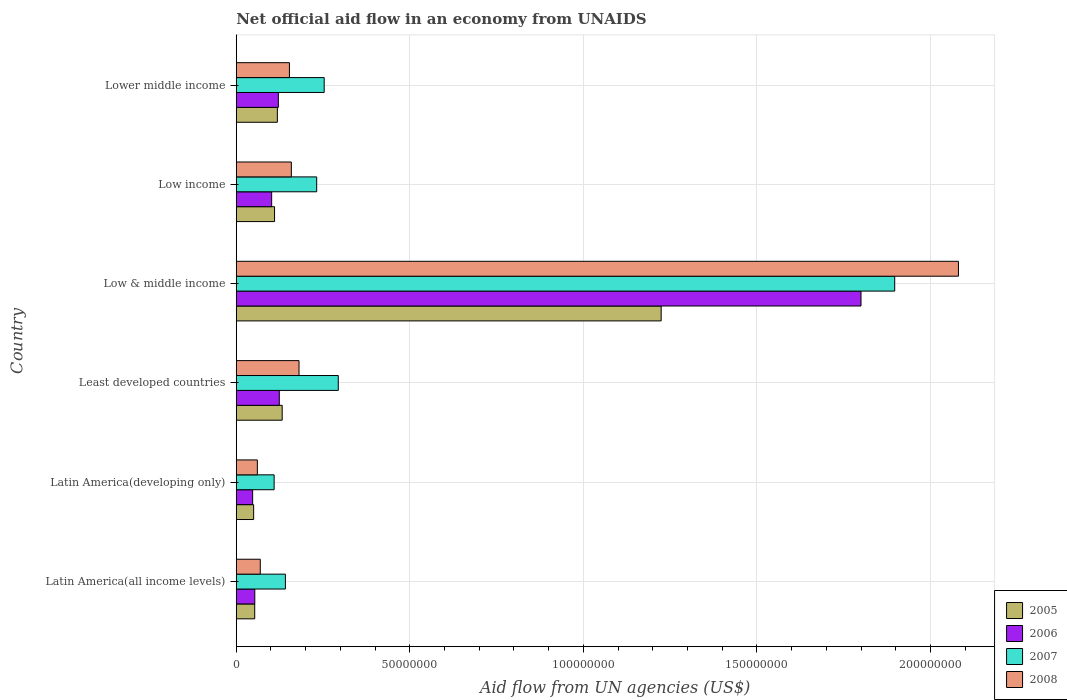How many groups of bars are there?
Provide a succinct answer. 6. Are the number of bars on each tick of the Y-axis equal?
Offer a terse response. Yes. How many bars are there on the 5th tick from the top?
Keep it short and to the point. 4. How many bars are there on the 1st tick from the bottom?
Your answer should be very brief. 4. What is the label of the 5th group of bars from the top?
Give a very brief answer. Latin America(developing only). What is the net official aid flow in 2008 in Latin America(developing only)?
Your response must be concise. 6.08e+06. Across all countries, what is the maximum net official aid flow in 2008?
Ensure brevity in your answer.  2.08e+08. Across all countries, what is the minimum net official aid flow in 2006?
Offer a terse response. 4.72e+06. In which country was the net official aid flow in 2008 minimum?
Ensure brevity in your answer.  Latin America(developing only). What is the total net official aid flow in 2005 in the graph?
Offer a very short reply. 1.69e+08. What is the difference between the net official aid flow in 2006 in Latin America(all income levels) and that in Low & middle income?
Provide a succinct answer. -1.75e+08. What is the difference between the net official aid flow in 2005 in Lower middle income and the net official aid flow in 2007 in Least developed countries?
Make the answer very short. -1.76e+07. What is the average net official aid flow in 2008 per country?
Give a very brief answer. 4.50e+07. What is the difference between the net official aid flow in 2007 and net official aid flow in 2006 in Latin America(all income levels)?
Offer a terse response. 8.82e+06. What is the ratio of the net official aid flow in 2008 in Latin America(all income levels) to that in Lower middle income?
Make the answer very short. 0.45. Is the net official aid flow in 2006 in Latin America(all income levels) less than that in Low & middle income?
Provide a succinct answer. Yes. Is the difference between the net official aid flow in 2007 in Latin America(all income levels) and Least developed countries greater than the difference between the net official aid flow in 2006 in Latin America(all income levels) and Least developed countries?
Ensure brevity in your answer.  No. What is the difference between the highest and the second highest net official aid flow in 2007?
Your response must be concise. 1.60e+08. What is the difference between the highest and the lowest net official aid flow in 2006?
Provide a short and direct response. 1.75e+08. In how many countries, is the net official aid flow in 2006 greater than the average net official aid flow in 2006 taken over all countries?
Ensure brevity in your answer.  1. Is the sum of the net official aid flow in 2007 in Low & middle income and Low income greater than the maximum net official aid flow in 2008 across all countries?
Your answer should be compact. Yes. What does the 1st bar from the bottom in Least developed countries represents?
Your response must be concise. 2005. Is it the case that in every country, the sum of the net official aid flow in 2005 and net official aid flow in 2006 is greater than the net official aid flow in 2007?
Keep it short and to the point. No. How many bars are there?
Your answer should be very brief. 24. Are all the bars in the graph horizontal?
Provide a succinct answer. Yes. Are the values on the major ticks of X-axis written in scientific E-notation?
Provide a short and direct response. No. Does the graph contain any zero values?
Keep it short and to the point. No. Does the graph contain grids?
Ensure brevity in your answer.  Yes. How many legend labels are there?
Ensure brevity in your answer.  4. What is the title of the graph?
Provide a succinct answer. Net official aid flow in an economy from UNAIDS. Does "2012" appear as one of the legend labels in the graph?
Make the answer very short. No. What is the label or title of the X-axis?
Give a very brief answer. Aid flow from UN agencies (US$). What is the Aid flow from UN agencies (US$) of 2005 in Latin America(all income levels)?
Your answer should be compact. 5.32e+06. What is the Aid flow from UN agencies (US$) in 2006 in Latin America(all income levels)?
Make the answer very short. 5.34e+06. What is the Aid flow from UN agencies (US$) of 2007 in Latin America(all income levels)?
Your response must be concise. 1.42e+07. What is the Aid flow from UN agencies (US$) in 2008 in Latin America(all income levels)?
Ensure brevity in your answer.  6.92e+06. What is the Aid flow from UN agencies (US$) of 2005 in Latin America(developing only)?
Your answer should be very brief. 5.01e+06. What is the Aid flow from UN agencies (US$) in 2006 in Latin America(developing only)?
Make the answer very short. 4.72e+06. What is the Aid flow from UN agencies (US$) of 2007 in Latin America(developing only)?
Ensure brevity in your answer.  1.09e+07. What is the Aid flow from UN agencies (US$) in 2008 in Latin America(developing only)?
Provide a succinct answer. 6.08e+06. What is the Aid flow from UN agencies (US$) in 2005 in Least developed countries?
Provide a succinct answer. 1.32e+07. What is the Aid flow from UN agencies (US$) in 2006 in Least developed countries?
Offer a very short reply. 1.24e+07. What is the Aid flow from UN agencies (US$) in 2007 in Least developed countries?
Provide a succinct answer. 2.94e+07. What is the Aid flow from UN agencies (US$) in 2008 in Least developed countries?
Offer a terse response. 1.81e+07. What is the Aid flow from UN agencies (US$) of 2005 in Low & middle income?
Your answer should be very brief. 1.22e+08. What is the Aid flow from UN agencies (US$) in 2006 in Low & middle income?
Your answer should be very brief. 1.80e+08. What is the Aid flow from UN agencies (US$) of 2007 in Low & middle income?
Ensure brevity in your answer.  1.90e+08. What is the Aid flow from UN agencies (US$) of 2008 in Low & middle income?
Provide a short and direct response. 2.08e+08. What is the Aid flow from UN agencies (US$) of 2005 in Low income?
Ensure brevity in your answer.  1.10e+07. What is the Aid flow from UN agencies (US$) of 2006 in Low income?
Your response must be concise. 1.02e+07. What is the Aid flow from UN agencies (US$) of 2007 in Low income?
Keep it short and to the point. 2.32e+07. What is the Aid flow from UN agencies (US$) of 2008 in Low income?
Your response must be concise. 1.59e+07. What is the Aid flow from UN agencies (US$) of 2005 in Lower middle income?
Your answer should be compact. 1.18e+07. What is the Aid flow from UN agencies (US$) of 2006 in Lower middle income?
Offer a terse response. 1.21e+07. What is the Aid flow from UN agencies (US$) of 2007 in Lower middle income?
Keep it short and to the point. 2.53e+07. What is the Aid flow from UN agencies (US$) in 2008 in Lower middle income?
Your response must be concise. 1.53e+07. Across all countries, what is the maximum Aid flow from UN agencies (US$) of 2005?
Provide a short and direct response. 1.22e+08. Across all countries, what is the maximum Aid flow from UN agencies (US$) of 2006?
Your response must be concise. 1.80e+08. Across all countries, what is the maximum Aid flow from UN agencies (US$) in 2007?
Your answer should be very brief. 1.90e+08. Across all countries, what is the maximum Aid flow from UN agencies (US$) of 2008?
Offer a very short reply. 2.08e+08. Across all countries, what is the minimum Aid flow from UN agencies (US$) in 2005?
Ensure brevity in your answer.  5.01e+06. Across all countries, what is the minimum Aid flow from UN agencies (US$) in 2006?
Provide a succinct answer. 4.72e+06. Across all countries, what is the minimum Aid flow from UN agencies (US$) in 2007?
Your answer should be very brief. 1.09e+07. Across all countries, what is the minimum Aid flow from UN agencies (US$) in 2008?
Provide a short and direct response. 6.08e+06. What is the total Aid flow from UN agencies (US$) of 2005 in the graph?
Your response must be concise. 1.69e+08. What is the total Aid flow from UN agencies (US$) of 2006 in the graph?
Your answer should be very brief. 2.25e+08. What is the total Aid flow from UN agencies (US$) of 2007 in the graph?
Give a very brief answer. 2.93e+08. What is the total Aid flow from UN agencies (US$) of 2008 in the graph?
Keep it short and to the point. 2.70e+08. What is the difference between the Aid flow from UN agencies (US$) of 2005 in Latin America(all income levels) and that in Latin America(developing only)?
Your answer should be very brief. 3.10e+05. What is the difference between the Aid flow from UN agencies (US$) of 2006 in Latin America(all income levels) and that in Latin America(developing only)?
Give a very brief answer. 6.20e+05. What is the difference between the Aid flow from UN agencies (US$) in 2007 in Latin America(all income levels) and that in Latin America(developing only)?
Make the answer very short. 3.25e+06. What is the difference between the Aid flow from UN agencies (US$) of 2008 in Latin America(all income levels) and that in Latin America(developing only)?
Keep it short and to the point. 8.40e+05. What is the difference between the Aid flow from UN agencies (US$) of 2005 in Latin America(all income levels) and that in Least developed countries?
Provide a short and direct response. -7.91e+06. What is the difference between the Aid flow from UN agencies (US$) in 2006 in Latin America(all income levels) and that in Least developed countries?
Provide a succinct answer. -7.06e+06. What is the difference between the Aid flow from UN agencies (US$) of 2007 in Latin America(all income levels) and that in Least developed countries?
Keep it short and to the point. -1.52e+07. What is the difference between the Aid flow from UN agencies (US$) of 2008 in Latin America(all income levels) and that in Least developed countries?
Ensure brevity in your answer.  -1.12e+07. What is the difference between the Aid flow from UN agencies (US$) in 2005 in Latin America(all income levels) and that in Low & middle income?
Your answer should be compact. -1.17e+08. What is the difference between the Aid flow from UN agencies (US$) of 2006 in Latin America(all income levels) and that in Low & middle income?
Give a very brief answer. -1.75e+08. What is the difference between the Aid flow from UN agencies (US$) in 2007 in Latin America(all income levels) and that in Low & middle income?
Ensure brevity in your answer.  -1.76e+08. What is the difference between the Aid flow from UN agencies (US$) of 2008 in Latin America(all income levels) and that in Low & middle income?
Offer a very short reply. -2.01e+08. What is the difference between the Aid flow from UN agencies (US$) of 2005 in Latin America(all income levels) and that in Low income?
Provide a short and direct response. -5.71e+06. What is the difference between the Aid flow from UN agencies (US$) in 2006 in Latin America(all income levels) and that in Low income?
Your answer should be compact. -4.86e+06. What is the difference between the Aid flow from UN agencies (US$) of 2007 in Latin America(all income levels) and that in Low income?
Provide a succinct answer. -9.01e+06. What is the difference between the Aid flow from UN agencies (US$) in 2008 in Latin America(all income levels) and that in Low income?
Ensure brevity in your answer.  -8.95e+06. What is the difference between the Aid flow from UN agencies (US$) in 2005 in Latin America(all income levels) and that in Lower middle income?
Your response must be concise. -6.52e+06. What is the difference between the Aid flow from UN agencies (US$) in 2006 in Latin America(all income levels) and that in Lower middle income?
Your response must be concise. -6.79e+06. What is the difference between the Aid flow from UN agencies (US$) in 2007 in Latin America(all income levels) and that in Lower middle income?
Offer a very short reply. -1.12e+07. What is the difference between the Aid flow from UN agencies (US$) in 2008 in Latin America(all income levels) and that in Lower middle income?
Provide a short and direct response. -8.40e+06. What is the difference between the Aid flow from UN agencies (US$) in 2005 in Latin America(developing only) and that in Least developed countries?
Give a very brief answer. -8.22e+06. What is the difference between the Aid flow from UN agencies (US$) of 2006 in Latin America(developing only) and that in Least developed countries?
Provide a succinct answer. -7.68e+06. What is the difference between the Aid flow from UN agencies (US$) of 2007 in Latin America(developing only) and that in Least developed countries?
Provide a succinct answer. -1.85e+07. What is the difference between the Aid flow from UN agencies (US$) of 2008 in Latin America(developing only) and that in Least developed countries?
Make the answer very short. -1.20e+07. What is the difference between the Aid flow from UN agencies (US$) of 2005 in Latin America(developing only) and that in Low & middle income?
Your answer should be compact. -1.17e+08. What is the difference between the Aid flow from UN agencies (US$) in 2006 in Latin America(developing only) and that in Low & middle income?
Give a very brief answer. -1.75e+08. What is the difference between the Aid flow from UN agencies (US$) in 2007 in Latin America(developing only) and that in Low & middle income?
Provide a short and direct response. -1.79e+08. What is the difference between the Aid flow from UN agencies (US$) in 2008 in Latin America(developing only) and that in Low & middle income?
Provide a short and direct response. -2.02e+08. What is the difference between the Aid flow from UN agencies (US$) in 2005 in Latin America(developing only) and that in Low income?
Keep it short and to the point. -6.02e+06. What is the difference between the Aid flow from UN agencies (US$) in 2006 in Latin America(developing only) and that in Low income?
Your answer should be very brief. -5.48e+06. What is the difference between the Aid flow from UN agencies (US$) in 2007 in Latin America(developing only) and that in Low income?
Provide a succinct answer. -1.23e+07. What is the difference between the Aid flow from UN agencies (US$) in 2008 in Latin America(developing only) and that in Low income?
Make the answer very short. -9.79e+06. What is the difference between the Aid flow from UN agencies (US$) in 2005 in Latin America(developing only) and that in Lower middle income?
Offer a very short reply. -6.83e+06. What is the difference between the Aid flow from UN agencies (US$) in 2006 in Latin America(developing only) and that in Lower middle income?
Provide a succinct answer. -7.41e+06. What is the difference between the Aid flow from UN agencies (US$) in 2007 in Latin America(developing only) and that in Lower middle income?
Provide a succinct answer. -1.44e+07. What is the difference between the Aid flow from UN agencies (US$) of 2008 in Latin America(developing only) and that in Lower middle income?
Your response must be concise. -9.24e+06. What is the difference between the Aid flow from UN agencies (US$) in 2005 in Least developed countries and that in Low & middle income?
Offer a very short reply. -1.09e+08. What is the difference between the Aid flow from UN agencies (US$) in 2006 in Least developed countries and that in Low & middle income?
Offer a very short reply. -1.68e+08. What is the difference between the Aid flow from UN agencies (US$) in 2007 in Least developed countries and that in Low & middle income?
Make the answer very short. -1.60e+08. What is the difference between the Aid flow from UN agencies (US$) of 2008 in Least developed countries and that in Low & middle income?
Ensure brevity in your answer.  -1.90e+08. What is the difference between the Aid flow from UN agencies (US$) of 2005 in Least developed countries and that in Low income?
Provide a short and direct response. 2.20e+06. What is the difference between the Aid flow from UN agencies (US$) in 2006 in Least developed countries and that in Low income?
Keep it short and to the point. 2.20e+06. What is the difference between the Aid flow from UN agencies (US$) of 2007 in Least developed countries and that in Low income?
Your answer should be compact. 6.22e+06. What is the difference between the Aid flow from UN agencies (US$) in 2008 in Least developed countries and that in Low income?
Ensure brevity in your answer.  2.21e+06. What is the difference between the Aid flow from UN agencies (US$) of 2005 in Least developed countries and that in Lower middle income?
Your response must be concise. 1.39e+06. What is the difference between the Aid flow from UN agencies (US$) of 2006 in Least developed countries and that in Lower middle income?
Ensure brevity in your answer.  2.70e+05. What is the difference between the Aid flow from UN agencies (US$) of 2007 in Least developed countries and that in Lower middle income?
Offer a very short reply. 4.06e+06. What is the difference between the Aid flow from UN agencies (US$) in 2008 in Least developed countries and that in Lower middle income?
Offer a very short reply. 2.76e+06. What is the difference between the Aid flow from UN agencies (US$) in 2005 in Low & middle income and that in Low income?
Give a very brief answer. 1.11e+08. What is the difference between the Aid flow from UN agencies (US$) in 2006 in Low & middle income and that in Low income?
Your answer should be very brief. 1.70e+08. What is the difference between the Aid flow from UN agencies (US$) in 2007 in Low & middle income and that in Low income?
Offer a very short reply. 1.66e+08. What is the difference between the Aid flow from UN agencies (US$) in 2008 in Low & middle income and that in Low income?
Make the answer very short. 1.92e+08. What is the difference between the Aid flow from UN agencies (US$) of 2005 in Low & middle income and that in Lower middle income?
Your answer should be compact. 1.11e+08. What is the difference between the Aid flow from UN agencies (US$) in 2006 in Low & middle income and that in Lower middle income?
Provide a short and direct response. 1.68e+08. What is the difference between the Aid flow from UN agencies (US$) in 2007 in Low & middle income and that in Lower middle income?
Offer a terse response. 1.64e+08. What is the difference between the Aid flow from UN agencies (US$) in 2008 in Low & middle income and that in Lower middle income?
Your answer should be compact. 1.93e+08. What is the difference between the Aid flow from UN agencies (US$) of 2005 in Low income and that in Lower middle income?
Offer a very short reply. -8.10e+05. What is the difference between the Aid flow from UN agencies (US$) of 2006 in Low income and that in Lower middle income?
Provide a short and direct response. -1.93e+06. What is the difference between the Aid flow from UN agencies (US$) in 2007 in Low income and that in Lower middle income?
Your answer should be compact. -2.16e+06. What is the difference between the Aid flow from UN agencies (US$) in 2008 in Low income and that in Lower middle income?
Provide a succinct answer. 5.50e+05. What is the difference between the Aid flow from UN agencies (US$) of 2005 in Latin America(all income levels) and the Aid flow from UN agencies (US$) of 2007 in Latin America(developing only)?
Keep it short and to the point. -5.59e+06. What is the difference between the Aid flow from UN agencies (US$) in 2005 in Latin America(all income levels) and the Aid flow from UN agencies (US$) in 2008 in Latin America(developing only)?
Offer a very short reply. -7.60e+05. What is the difference between the Aid flow from UN agencies (US$) in 2006 in Latin America(all income levels) and the Aid flow from UN agencies (US$) in 2007 in Latin America(developing only)?
Offer a terse response. -5.57e+06. What is the difference between the Aid flow from UN agencies (US$) of 2006 in Latin America(all income levels) and the Aid flow from UN agencies (US$) of 2008 in Latin America(developing only)?
Make the answer very short. -7.40e+05. What is the difference between the Aid flow from UN agencies (US$) in 2007 in Latin America(all income levels) and the Aid flow from UN agencies (US$) in 2008 in Latin America(developing only)?
Keep it short and to the point. 8.08e+06. What is the difference between the Aid flow from UN agencies (US$) of 2005 in Latin America(all income levels) and the Aid flow from UN agencies (US$) of 2006 in Least developed countries?
Ensure brevity in your answer.  -7.08e+06. What is the difference between the Aid flow from UN agencies (US$) of 2005 in Latin America(all income levels) and the Aid flow from UN agencies (US$) of 2007 in Least developed countries?
Your answer should be very brief. -2.41e+07. What is the difference between the Aid flow from UN agencies (US$) in 2005 in Latin America(all income levels) and the Aid flow from UN agencies (US$) in 2008 in Least developed countries?
Make the answer very short. -1.28e+07. What is the difference between the Aid flow from UN agencies (US$) of 2006 in Latin America(all income levels) and the Aid flow from UN agencies (US$) of 2007 in Least developed countries?
Offer a very short reply. -2.40e+07. What is the difference between the Aid flow from UN agencies (US$) in 2006 in Latin America(all income levels) and the Aid flow from UN agencies (US$) in 2008 in Least developed countries?
Your answer should be very brief. -1.27e+07. What is the difference between the Aid flow from UN agencies (US$) in 2007 in Latin America(all income levels) and the Aid flow from UN agencies (US$) in 2008 in Least developed countries?
Your answer should be very brief. -3.92e+06. What is the difference between the Aid flow from UN agencies (US$) of 2005 in Latin America(all income levels) and the Aid flow from UN agencies (US$) of 2006 in Low & middle income?
Offer a very short reply. -1.75e+08. What is the difference between the Aid flow from UN agencies (US$) of 2005 in Latin America(all income levels) and the Aid flow from UN agencies (US$) of 2007 in Low & middle income?
Give a very brief answer. -1.84e+08. What is the difference between the Aid flow from UN agencies (US$) in 2005 in Latin America(all income levels) and the Aid flow from UN agencies (US$) in 2008 in Low & middle income?
Offer a very short reply. -2.03e+08. What is the difference between the Aid flow from UN agencies (US$) in 2006 in Latin America(all income levels) and the Aid flow from UN agencies (US$) in 2007 in Low & middle income?
Ensure brevity in your answer.  -1.84e+08. What is the difference between the Aid flow from UN agencies (US$) in 2006 in Latin America(all income levels) and the Aid flow from UN agencies (US$) in 2008 in Low & middle income?
Offer a terse response. -2.03e+08. What is the difference between the Aid flow from UN agencies (US$) of 2007 in Latin America(all income levels) and the Aid flow from UN agencies (US$) of 2008 in Low & middle income?
Give a very brief answer. -1.94e+08. What is the difference between the Aid flow from UN agencies (US$) in 2005 in Latin America(all income levels) and the Aid flow from UN agencies (US$) in 2006 in Low income?
Offer a terse response. -4.88e+06. What is the difference between the Aid flow from UN agencies (US$) in 2005 in Latin America(all income levels) and the Aid flow from UN agencies (US$) in 2007 in Low income?
Provide a succinct answer. -1.78e+07. What is the difference between the Aid flow from UN agencies (US$) of 2005 in Latin America(all income levels) and the Aid flow from UN agencies (US$) of 2008 in Low income?
Your answer should be compact. -1.06e+07. What is the difference between the Aid flow from UN agencies (US$) in 2006 in Latin America(all income levels) and the Aid flow from UN agencies (US$) in 2007 in Low income?
Your answer should be compact. -1.78e+07. What is the difference between the Aid flow from UN agencies (US$) in 2006 in Latin America(all income levels) and the Aid flow from UN agencies (US$) in 2008 in Low income?
Your answer should be compact. -1.05e+07. What is the difference between the Aid flow from UN agencies (US$) in 2007 in Latin America(all income levels) and the Aid flow from UN agencies (US$) in 2008 in Low income?
Offer a very short reply. -1.71e+06. What is the difference between the Aid flow from UN agencies (US$) in 2005 in Latin America(all income levels) and the Aid flow from UN agencies (US$) in 2006 in Lower middle income?
Make the answer very short. -6.81e+06. What is the difference between the Aid flow from UN agencies (US$) in 2005 in Latin America(all income levels) and the Aid flow from UN agencies (US$) in 2007 in Lower middle income?
Provide a short and direct response. -2.00e+07. What is the difference between the Aid flow from UN agencies (US$) of 2005 in Latin America(all income levels) and the Aid flow from UN agencies (US$) of 2008 in Lower middle income?
Ensure brevity in your answer.  -1.00e+07. What is the difference between the Aid flow from UN agencies (US$) of 2006 in Latin America(all income levels) and the Aid flow from UN agencies (US$) of 2007 in Lower middle income?
Your response must be concise. -2.00e+07. What is the difference between the Aid flow from UN agencies (US$) of 2006 in Latin America(all income levels) and the Aid flow from UN agencies (US$) of 2008 in Lower middle income?
Your response must be concise. -9.98e+06. What is the difference between the Aid flow from UN agencies (US$) in 2007 in Latin America(all income levels) and the Aid flow from UN agencies (US$) in 2008 in Lower middle income?
Your answer should be compact. -1.16e+06. What is the difference between the Aid flow from UN agencies (US$) of 2005 in Latin America(developing only) and the Aid flow from UN agencies (US$) of 2006 in Least developed countries?
Offer a terse response. -7.39e+06. What is the difference between the Aid flow from UN agencies (US$) in 2005 in Latin America(developing only) and the Aid flow from UN agencies (US$) in 2007 in Least developed countries?
Your answer should be compact. -2.44e+07. What is the difference between the Aid flow from UN agencies (US$) of 2005 in Latin America(developing only) and the Aid flow from UN agencies (US$) of 2008 in Least developed countries?
Keep it short and to the point. -1.31e+07. What is the difference between the Aid flow from UN agencies (US$) in 2006 in Latin America(developing only) and the Aid flow from UN agencies (US$) in 2007 in Least developed countries?
Ensure brevity in your answer.  -2.47e+07. What is the difference between the Aid flow from UN agencies (US$) in 2006 in Latin America(developing only) and the Aid flow from UN agencies (US$) in 2008 in Least developed countries?
Provide a succinct answer. -1.34e+07. What is the difference between the Aid flow from UN agencies (US$) of 2007 in Latin America(developing only) and the Aid flow from UN agencies (US$) of 2008 in Least developed countries?
Keep it short and to the point. -7.17e+06. What is the difference between the Aid flow from UN agencies (US$) of 2005 in Latin America(developing only) and the Aid flow from UN agencies (US$) of 2006 in Low & middle income?
Make the answer very short. -1.75e+08. What is the difference between the Aid flow from UN agencies (US$) in 2005 in Latin America(developing only) and the Aid flow from UN agencies (US$) in 2007 in Low & middle income?
Your answer should be compact. -1.85e+08. What is the difference between the Aid flow from UN agencies (US$) in 2005 in Latin America(developing only) and the Aid flow from UN agencies (US$) in 2008 in Low & middle income?
Keep it short and to the point. -2.03e+08. What is the difference between the Aid flow from UN agencies (US$) of 2006 in Latin America(developing only) and the Aid flow from UN agencies (US$) of 2007 in Low & middle income?
Keep it short and to the point. -1.85e+08. What is the difference between the Aid flow from UN agencies (US$) in 2006 in Latin America(developing only) and the Aid flow from UN agencies (US$) in 2008 in Low & middle income?
Provide a short and direct response. -2.03e+08. What is the difference between the Aid flow from UN agencies (US$) of 2007 in Latin America(developing only) and the Aid flow from UN agencies (US$) of 2008 in Low & middle income?
Your answer should be compact. -1.97e+08. What is the difference between the Aid flow from UN agencies (US$) in 2005 in Latin America(developing only) and the Aid flow from UN agencies (US$) in 2006 in Low income?
Ensure brevity in your answer.  -5.19e+06. What is the difference between the Aid flow from UN agencies (US$) in 2005 in Latin America(developing only) and the Aid flow from UN agencies (US$) in 2007 in Low income?
Your response must be concise. -1.82e+07. What is the difference between the Aid flow from UN agencies (US$) in 2005 in Latin America(developing only) and the Aid flow from UN agencies (US$) in 2008 in Low income?
Provide a succinct answer. -1.09e+07. What is the difference between the Aid flow from UN agencies (US$) in 2006 in Latin America(developing only) and the Aid flow from UN agencies (US$) in 2007 in Low income?
Your answer should be very brief. -1.84e+07. What is the difference between the Aid flow from UN agencies (US$) in 2006 in Latin America(developing only) and the Aid flow from UN agencies (US$) in 2008 in Low income?
Provide a succinct answer. -1.12e+07. What is the difference between the Aid flow from UN agencies (US$) in 2007 in Latin America(developing only) and the Aid flow from UN agencies (US$) in 2008 in Low income?
Your answer should be very brief. -4.96e+06. What is the difference between the Aid flow from UN agencies (US$) in 2005 in Latin America(developing only) and the Aid flow from UN agencies (US$) in 2006 in Lower middle income?
Your answer should be compact. -7.12e+06. What is the difference between the Aid flow from UN agencies (US$) in 2005 in Latin America(developing only) and the Aid flow from UN agencies (US$) in 2007 in Lower middle income?
Make the answer very short. -2.03e+07. What is the difference between the Aid flow from UN agencies (US$) in 2005 in Latin America(developing only) and the Aid flow from UN agencies (US$) in 2008 in Lower middle income?
Provide a succinct answer. -1.03e+07. What is the difference between the Aid flow from UN agencies (US$) of 2006 in Latin America(developing only) and the Aid flow from UN agencies (US$) of 2007 in Lower middle income?
Offer a terse response. -2.06e+07. What is the difference between the Aid flow from UN agencies (US$) of 2006 in Latin America(developing only) and the Aid flow from UN agencies (US$) of 2008 in Lower middle income?
Offer a terse response. -1.06e+07. What is the difference between the Aid flow from UN agencies (US$) in 2007 in Latin America(developing only) and the Aid flow from UN agencies (US$) in 2008 in Lower middle income?
Offer a terse response. -4.41e+06. What is the difference between the Aid flow from UN agencies (US$) of 2005 in Least developed countries and the Aid flow from UN agencies (US$) of 2006 in Low & middle income?
Offer a very short reply. -1.67e+08. What is the difference between the Aid flow from UN agencies (US$) in 2005 in Least developed countries and the Aid flow from UN agencies (US$) in 2007 in Low & middle income?
Your response must be concise. -1.76e+08. What is the difference between the Aid flow from UN agencies (US$) of 2005 in Least developed countries and the Aid flow from UN agencies (US$) of 2008 in Low & middle income?
Your answer should be compact. -1.95e+08. What is the difference between the Aid flow from UN agencies (US$) of 2006 in Least developed countries and the Aid flow from UN agencies (US$) of 2007 in Low & middle income?
Ensure brevity in your answer.  -1.77e+08. What is the difference between the Aid flow from UN agencies (US$) of 2006 in Least developed countries and the Aid flow from UN agencies (US$) of 2008 in Low & middle income?
Offer a terse response. -1.96e+08. What is the difference between the Aid flow from UN agencies (US$) of 2007 in Least developed countries and the Aid flow from UN agencies (US$) of 2008 in Low & middle income?
Keep it short and to the point. -1.79e+08. What is the difference between the Aid flow from UN agencies (US$) in 2005 in Least developed countries and the Aid flow from UN agencies (US$) in 2006 in Low income?
Offer a terse response. 3.03e+06. What is the difference between the Aid flow from UN agencies (US$) of 2005 in Least developed countries and the Aid flow from UN agencies (US$) of 2007 in Low income?
Your answer should be very brief. -9.94e+06. What is the difference between the Aid flow from UN agencies (US$) of 2005 in Least developed countries and the Aid flow from UN agencies (US$) of 2008 in Low income?
Give a very brief answer. -2.64e+06. What is the difference between the Aid flow from UN agencies (US$) of 2006 in Least developed countries and the Aid flow from UN agencies (US$) of 2007 in Low income?
Offer a terse response. -1.08e+07. What is the difference between the Aid flow from UN agencies (US$) in 2006 in Least developed countries and the Aid flow from UN agencies (US$) in 2008 in Low income?
Your answer should be compact. -3.47e+06. What is the difference between the Aid flow from UN agencies (US$) of 2007 in Least developed countries and the Aid flow from UN agencies (US$) of 2008 in Low income?
Provide a short and direct response. 1.35e+07. What is the difference between the Aid flow from UN agencies (US$) in 2005 in Least developed countries and the Aid flow from UN agencies (US$) in 2006 in Lower middle income?
Make the answer very short. 1.10e+06. What is the difference between the Aid flow from UN agencies (US$) of 2005 in Least developed countries and the Aid flow from UN agencies (US$) of 2007 in Lower middle income?
Keep it short and to the point. -1.21e+07. What is the difference between the Aid flow from UN agencies (US$) in 2005 in Least developed countries and the Aid flow from UN agencies (US$) in 2008 in Lower middle income?
Keep it short and to the point. -2.09e+06. What is the difference between the Aid flow from UN agencies (US$) in 2006 in Least developed countries and the Aid flow from UN agencies (US$) in 2007 in Lower middle income?
Provide a succinct answer. -1.29e+07. What is the difference between the Aid flow from UN agencies (US$) in 2006 in Least developed countries and the Aid flow from UN agencies (US$) in 2008 in Lower middle income?
Your answer should be very brief. -2.92e+06. What is the difference between the Aid flow from UN agencies (US$) of 2007 in Least developed countries and the Aid flow from UN agencies (US$) of 2008 in Lower middle income?
Your answer should be very brief. 1.41e+07. What is the difference between the Aid flow from UN agencies (US$) of 2005 in Low & middle income and the Aid flow from UN agencies (US$) of 2006 in Low income?
Provide a succinct answer. 1.12e+08. What is the difference between the Aid flow from UN agencies (US$) in 2005 in Low & middle income and the Aid flow from UN agencies (US$) in 2007 in Low income?
Ensure brevity in your answer.  9.92e+07. What is the difference between the Aid flow from UN agencies (US$) in 2005 in Low & middle income and the Aid flow from UN agencies (US$) in 2008 in Low income?
Your answer should be very brief. 1.07e+08. What is the difference between the Aid flow from UN agencies (US$) in 2006 in Low & middle income and the Aid flow from UN agencies (US$) in 2007 in Low income?
Offer a very short reply. 1.57e+08. What is the difference between the Aid flow from UN agencies (US$) of 2006 in Low & middle income and the Aid flow from UN agencies (US$) of 2008 in Low income?
Give a very brief answer. 1.64e+08. What is the difference between the Aid flow from UN agencies (US$) of 2007 in Low & middle income and the Aid flow from UN agencies (US$) of 2008 in Low income?
Provide a short and direct response. 1.74e+08. What is the difference between the Aid flow from UN agencies (US$) of 2005 in Low & middle income and the Aid flow from UN agencies (US$) of 2006 in Lower middle income?
Keep it short and to the point. 1.10e+08. What is the difference between the Aid flow from UN agencies (US$) of 2005 in Low & middle income and the Aid flow from UN agencies (US$) of 2007 in Lower middle income?
Ensure brevity in your answer.  9.71e+07. What is the difference between the Aid flow from UN agencies (US$) of 2005 in Low & middle income and the Aid flow from UN agencies (US$) of 2008 in Lower middle income?
Offer a very short reply. 1.07e+08. What is the difference between the Aid flow from UN agencies (US$) in 2006 in Low & middle income and the Aid flow from UN agencies (US$) in 2007 in Lower middle income?
Your answer should be very brief. 1.55e+08. What is the difference between the Aid flow from UN agencies (US$) in 2006 in Low & middle income and the Aid flow from UN agencies (US$) in 2008 in Lower middle income?
Offer a very short reply. 1.65e+08. What is the difference between the Aid flow from UN agencies (US$) in 2007 in Low & middle income and the Aid flow from UN agencies (US$) in 2008 in Lower middle income?
Offer a terse response. 1.74e+08. What is the difference between the Aid flow from UN agencies (US$) of 2005 in Low income and the Aid flow from UN agencies (US$) of 2006 in Lower middle income?
Keep it short and to the point. -1.10e+06. What is the difference between the Aid flow from UN agencies (US$) in 2005 in Low income and the Aid flow from UN agencies (US$) in 2007 in Lower middle income?
Make the answer very short. -1.43e+07. What is the difference between the Aid flow from UN agencies (US$) in 2005 in Low income and the Aid flow from UN agencies (US$) in 2008 in Lower middle income?
Make the answer very short. -4.29e+06. What is the difference between the Aid flow from UN agencies (US$) of 2006 in Low income and the Aid flow from UN agencies (US$) of 2007 in Lower middle income?
Make the answer very short. -1.51e+07. What is the difference between the Aid flow from UN agencies (US$) of 2006 in Low income and the Aid flow from UN agencies (US$) of 2008 in Lower middle income?
Your response must be concise. -5.12e+06. What is the difference between the Aid flow from UN agencies (US$) of 2007 in Low income and the Aid flow from UN agencies (US$) of 2008 in Lower middle income?
Provide a succinct answer. 7.85e+06. What is the average Aid flow from UN agencies (US$) of 2005 per country?
Your answer should be very brief. 2.81e+07. What is the average Aid flow from UN agencies (US$) in 2006 per country?
Provide a succinct answer. 3.75e+07. What is the average Aid flow from UN agencies (US$) in 2007 per country?
Give a very brief answer. 4.88e+07. What is the average Aid flow from UN agencies (US$) of 2008 per country?
Offer a terse response. 4.50e+07. What is the difference between the Aid flow from UN agencies (US$) in 2005 and Aid flow from UN agencies (US$) in 2007 in Latin America(all income levels)?
Your answer should be very brief. -8.84e+06. What is the difference between the Aid flow from UN agencies (US$) in 2005 and Aid flow from UN agencies (US$) in 2008 in Latin America(all income levels)?
Make the answer very short. -1.60e+06. What is the difference between the Aid flow from UN agencies (US$) in 2006 and Aid flow from UN agencies (US$) in 2007 in Latin America(all income levels)?
Your answer should be compact. -8.82e+06. What is the difference between the Aid flow from UN agencies (US$) in 2006 and Aid flow from UN agencies (US$) in 2008 in Latin America(all income levels)?
Your answer should be compact. -1.58e+06. What is the difference between the Aid flow from UN agencies (US$) in 2007 and Aid flow from UN agencies (US$) in 2008 in Latin America(all income levels)?
Your answer should be compact. 7.24e+06. What is the difference between the Aid flow from UN agencies (US$) of 2005 and Aid flow from UN agencies (US$) of 2006 in Latin America(developing only)?
Ensure brevity in your answer.  2.90e+05. What is the difference between the Aid flow from UN agencies (US$) of 2005 and Aid flow from UN agencies (US$) of 2007 in Latin America(developing only)?
Offer a very short reply. -5.90e+06. What is the difference between the Aid flow from UN agencies (US$) of 2005 and Aid flow from UN agencies (US$) of 2008 in Latin America(developing only)?
Give a very brief answer. -1.07e+06. What is the difference between the Aid flow from UN agencies (US$) of 2006 and Aid flow from UN agencies (US$) of 2007 in Latin America(developing only)?
Offer a terse response. -6.19e+06. What is the difference between the Aid flow from UN agencies (US$) in 2006 and Aid flow from UN agencies (US$) in 2008 in Latin America(developing only)?
Provide a succinct answer. -1.36e+06. What is the difference between the Aid flow from UN agencies (US$) of 2007 and Aid flow from UN agencies (US$) of 2008 in Latin America(developing only)?
Provide a succinct answer. 4.83e+06. What is the difference between the Aid flow from UN agencies (US$) of 2005 and Aid flow from UN agencies (US$) of 2006 in Least developed countries?
Ensure brevity in your answer.  8.30e+05. What is the difference between the Aid flow from UN agencies (US$) in 2005 and Aid flow from UN agencies (US$) in 2007 in Least developed countries?
Provide a short and direct response. -1.62e+07. What is the difference between the Aid flow from UN agencies (US$) of 2005 and Aid flow from UN agencies (US$) of 2008 in Least developed countries?
Keep it short and to the point. -4.85e+06. What is the difference between the Aid flow from UN agencies (US$) in 2006 and Aid flow from UN agencies (US$) in 2007 in Least developed countries?
Provide a short and direct response. -1.70e+07. What is the difference between the Aid flow from UN agencies (US$) in 2006 and Aid flow from UN agencies (US$) in 2008 in Least developed countries?
Provide a succinct answer. -5.68e+06. What is the difference between the Aid flow from UN agencies (US$) of 2007 and Aid flow from UN agencies (US$) of 2008 in Least developed countries?
Make the answer very short. 1.13e+07. What is the difference between the Aid flow from UN agencies (US$) of 2005 and Aid flow from UN agencies (US$) of 2006 in Low & middle income?
Your response must be concise. -5.76e+07. What is the difference between the Aid flow from UN agencies (US$) of 2005 and Aid flow from UN agencies (US$) of 2007 in Low & middle income?
Give a very brief answer. -6.73e+07. What is the difference between the Aid flow from UN agencies (US$) in 2005 and Aid flow from UN agencies (US$) in 2008 in Low & middle income?
Provide a succinct answer. -8.56e+07. What is the difference between the Aid flow from UN agencies (US$) in 2006 and Aid flow from UN agencies (US$) in 2007 in Low & middle income?
Your answer should be compact. -9.71e+06. What is the difference between the Aid flow from UN agencies (US$) in 2006 and Aid flow from UN agencies (US$) in 2008 in Low & middle income?
Make the answer very short. -2.81e+07. What is the difference between the Aid flow from UN agencies (US$) of 2007 and Aid flow from UN agencies (US$) of 2008 in Low & middle income?
Your response must be concise. -1.84e+07. What is the difference between the Aid flow from UN agencies (US$) of 2005 and Aid flow from UN agencies (US$) of 2006 in Low income?
Keep it short and to the point. 8.30e+05. What is the difference between the Aid flow from UN agencies (US$) of 2005 and Aid flow from UN agencies (US$) of 2007 in Low income?
Offer a terse response. -1.21e+07. What is the difference between the Aid flow from UN agencies (US$) in 2005 and Aid flow from UN agencies (US$) in 2008 in Low income?
Ensure brevity in your answer.  -4.84e+06. What is the difference between the Aid flow from UN agencies (US$) of 2006 and Aid flow from UN agencies (US$) of 2007 in Low income?
Your answer should be compact. -1.30e+07. What is the difference between the Aid flow from UN agencies (US$) of 2006 and Aid flow from UN agencies (US$) of 2008 in Low income?
Offer a terse response. -5.67e+06. What is the difference between the Aid flow from UN agencies (US$) of 2007 and Aid flow from UN agencies (US$) of 2008 in Low income?
Your response must be concise. 7.30e+06. What is the difference between the Aid flow from UN agencies (US$) of 2005 and Aid flow from UN agencies (US$) of 2006 in Lower middle income?
Offer a terse response. -2.90e+05. What is the difference between the Aid flow from UN agencies (US$) in 2005 and Aid flow from UN agencies (US$) in 2007 in Lower middle income?
Keep it short and to the point. -1.35e+07. What is the difference between the Aid flow from UN agencies (US$) in 2005 and Aid flow from UN agencies (US$) in 2008 in Lower middle income?
Your response must be concise. -3.48e+06. What is the difference between the Aid flow from UN agencies (US$) of 2006 and Aid flow from UN agencies (US$) of 2007 in Lower middle income?
Offer a very short reply. -1.32e+07. What is the difference between the Aid flow from UN agencies (US$) of 2006 and Aid flow from UN agencies (US$) of 2008 in Lower middle income?
Your answer should be very brief. -3.19e+06. What is the difference between the Aid flow from UN agencies (US$) in 2007 and Aid flow from UN agencies (US$) in 2008 in Lower middle income?
Provide a succinct answer. 1.00e+07. What is the ratio of the Aid flow from UN agencies (US$) of 2005 in Latin America(all income levels) to that in Latin America(developing only)?
Keep it short and to the point. 1.06. What is the ratio of the Aid flow from UN agencies (US$) of 2006 in Latin America(all income levels) to that in Latin America(developing only)?
Provide a succinct answer. 1.13. What is the ratio of the Aid flow from UN agencies (US$) in 2007 in Latin America(all income levels) to that in Latin America(developing only)?
Your answer should be very brief. 1.3. What is the ratio of the Aid flow from UN agencies (US$) of 2008 in Latin America(all income levels) to that in Latin America(developing only)?
Offer a terse response. 1.14. What is the ratio of the Aid flow from UN agencies (US$) of 2005 in Latin America(all income levels) to that in Least developed countries?
Your answer should be compact. 0.4. What is the ratio of the Aid flow from UN agencies (US$) in 2006 in Latin America(all income levels) to that in Least developed countries?
Give a very brief answer. 0.43. What is the ratio of the Aid flow from UN agencies (US$) of 2007 in Latin America(all income levels) to that in Least developed countries?
Offer a terse response. 0.48. What is the ratio of the Aid flow from UN agencies (US$) of 2008 in Latin America(all income levels) to that in Least developed countries?
Provide a succinct answer. 0.38. What is the ratio of the Aid flow from UN agencies (US$) of 2005 in Latin America(all income levels) to that in Low & middle income?
Provide a short and direct response. 0.04. What is the ratio of the Aid flow from UN agencies (US$) of 2006 in Latin America(all income levels) to that in Low & middle income?
Your response must be concise. 0.03. What is the ratio of the Aid flow from UN agencies (US$) in 2007 in Latin America(all income levels) to that in Low & middle income?
Ensure brevity in your answer.  0.07. What is the ratio of the Aid flow from UN agencies (US$) of 2005 in Latin America(all income levels) to that in Low income?
Provide a short and direct response. 0.48. What is the ratio of the Aid flow from UN agencies (US$) in 2006 in Latin America(all income levels) to that in Low income?
Keep it short and to the point. 0.52. What is the ratio of the Aid flow from UN agencies (US$) of 2007 in Latin America(all income levels) to that in Low income?
Give a very brief answer. 0.61. What is the ratio of the Aid flow from UN agencies (US$) in 2008 in Latin America(all income levels) to that in Low income?
Offer a very short reply. 0.44. What is the ratio of the Aid flow from UN agencies (US$) of 2005 in Latin America(all income levels) to that in Lower middle income?
Make the answer very short. 0.45. What is the ratio of the Aid flow from UN agencies (US$) in 2006 in Latin America(all income levels) to that in Lower middle income?
Your response must be concise. 0.44. What is the ratio of the Aid flow from UN agencies (US$) in 2007 in Latin America(all income levels) to that in Lower middle income?
Offer a very short reply. 0.56. What is the ratio of the Aid flow from UN agencies (US$) of 2008 in Latin America(all income levels) to that in Lower middle income?
Give a very brief answer. 0.45. What is the ratio of the Aid flow from UN agencies (US$) in 2005 in Latin America(developing only) to that in Least developed countries?
Provide a succinct answer. 0.38. What is the ratio of the Aid flow from UN agencies (US$) in 2006 in Latin America(developing only) to that in Least developed countries?
Make the answer very short. 0.38. What is the ratio of the Aid flow from UN agencies (US$) of 2007 in Latin America(developing only) to that in Least developed countries?
Provide a succinct answer. 0.37. What is the ratio of the Aid flow from UN agencies (US$) of 2008 in Latin America(developing only) to that in Least developed countries?
Ensure brevity in your answer.  0.34. What is the ratio of the Aid flow from UN agencies (US$) in 2005 in Latin America(developing only) to that in Low & middle income?
Your response must be concise. 0.04. What is the ratio of the Aid flow from UN agencies (US$) of 2006 in Latin America(developing only) to that in Low & middle income?
Your answer should be very brief. 0.03. What is the ratio of the Aid flow from UN agencies (US$) in 2007 in Latin America(developing only) to that in Low & middle income?
Ensure brevity in your answer.  0.06. What is the ratio of the Aid flow from UN agencies (US$) of 2008 in Latin America(developing only) to that in Low & middle income?
Ensure brevity in your answer.  0.03. What is the ratio of the Aid flow from UN agencies (US$) of 2005 in Latin America(developing only) to that in Low income?
Offer a very short reply. 0.45. What is the ratio of the Aid flow from UN agencies (US$) in 2006 in Latin America(developing only) to that in Low income?
Provide a short and direct response. 0.46. What is the ratio of the Aid flow from UN agencies (US$) in 2007 in Latin America(developing only) to that in Low income?
Provide a short and direct response. 0.47. What is the ratio of the Aid flow from UN agencies (US$) in 2008 in Latin America(developing only) to that in Low income?
Your answer should be very brief. 0.38. What is the ratio of the Aid flow from UN agencies (US$) of 2005 in Latin America(developing only) to that in Lower middle income?
Provide a succinct answer. 0.42. What is the ratio of the Aid flow from UN agencies (US$) of 2006 in Latin America(developing only) to that in Lower middle income?
Offer a very short reply. 0.39. What is the ratio of the Aid flow from UN agencies (US$) in 2007 in Latin America(developing only) to that in Lower middle income?
Give a very brief answer. 0.43. What is the ratio of the Aid flow from UN agencies (US$) of 2008 in Latin America(developing only) to that in Lower middle income?
Give a very brief answer. 0.4. What is the ratio of the Aid flow from UN agencies (US$) in 2005 in Least developed countries to that in Low & middle income?
Give a very brief answer. 0.11. What is the ratio of the Aid flow from UN agencies (US$) of 2006 in Least developed countries to that in Low & middle income?
Offer a very short reply. 0.07. What is the ratio of the Aid flow from UN agencies (US$) in 2007 in Least developed countries to that in Low & middle income?
Provide a succinct answer. 0.15. What is the ratio of the Aid flow from UN agencies (US$) in 2008 in Least developed countries to that in Low & middle income?
Provide a short and direct response. 0.09. What is the ratio of the Aid flow from UN agencies (US$) of 2005 in Least developed countries to that in Low income?
Offer a very short reply. 1.2. What is the ratio of the Aid flow from UN agencies (US$) of 2006 in Least developed countries to that in Low income?
Your response must be concise. 1.22. What is the ratio of the Aid flow from UN agencies (US$) of 2007 in Least developed countries to that in Low income?
Make the answer very short. 1.27. What is the ratio of the Aid flow from UN agencies (US$) of 2008 in Least developed countries to that in Low income?
Your answer should be compact. 1.14. What is the ratio of the Aid flow from UN agencies (US$) in 2005 in Least developed countries to that in Lower middle income?
Offer a very short reply. 1.12. What is the ratio of the Aid flow from UN agencies (US$) in 2006 in Least developed countries to that in Lower middle income?
Your answer should be compact. 1.02. What is the ratio of the Aid flow from UN agencies (US$) in 2007 in Least developed countries to that in Lower middle income?
Your answer should be very brief. 1.16. What is the ratio of the Aid flow from UN agencies (US$) of 2008 in Least developed countries to that in Lower middle income?
Keep it short and to the point. 1.18. What is the ratio of the Aid flow from UN agencies (US$) of 2005 in Low & middle income to that in Low income?
Provide a short and direct response. 11.1. What is the ratio of the Aid flow from UN agencies (US$) of 2006 in Low & middle income to that in Low income?
Keep it short and to the point. 17.64. What is the ratio of the Aid flow from UN agencies (US$) in 2007 in Low & middle income to that in Low income?
Your answer should be very brief. 8.19. What is the ratio of the Aid flow from UN agencies (US$) in 2008 in Low & middle income to that in Low income?
Ensure brevity in your answer.  13.11. What is the ratio of the Aid flow from UN agencies (US$) in 2005 in Low & middle income to that in Lower middle income?
Give a very brief answer. 10.34. What is the ratio of the Aid flow from UN agencies (US$) of 2006 in Low & middle income to that in Lower middle income?
Offer a very short reply. 14.84. What is the ratio of the Aid flow from UN agencies (US$) of 2007 in Low & middle income to that in Lower middle income?
Provide a succinct answer. 7.49. What is the ratio of the Aid flow from UN agencies (US$) in 2008 in Low & middle income to that in Lower middle income?
Your answer should be compact. 13.58. What is the ratio of the Aid flow from UN agencies (US$) of 2005 in Low income to that in Lower middle income?
Keep it short and to the point. 0.93. What is the ratio of the Aid flow from UN agencies (US$) of 2006 in Low income to that in Lower middle income?
Ensure brevity in your answer.  0.84. What is the ratio of the Aid flow from UN agencies (US$) in 2007 in Low income to that in Lower middle income?
Give a very brief answer. 0.91. What is the ratio of the Aid flow from UN agencies (US$) in 2008 in Low income to that in Lower middle income?
Offer a very short reply. 1.04. What is the difference between the highest and the second highest Aid flow from UN agencies (US$) of 2005?
Offer a terse response. 1.09e+08. What is the difference between the highest and the second highest Aid flow from UN agencies (US$) in 2006?
Make the answer very short. 1.68e+08. What is the difference between the highest and the second highest Aid flow from UN agencies (US$) of 2007?
Provide a short and direct response. 1.60e+08. What is the difference between the highest and the second highest Aid flow from UN agencies (US$) in 2008?
Offer a terse response. 1.90e+08. What is the difference between the highest and the lowest Aid flow from UN agencies (US$) of 2005?
Offer a very short reply. 1.17e+08. What is the difference between the highest and the lowest Aid flow from UN agencies (US$) of 2006?
Your response must be concise. 1.75e+08. What is the difference between the highest and the lowest Aid flow from UN agencies (US$) in 2007?
Make the answer very short. 1.79e+08. What is the difference between the highest and the lowest Aid flow from UN agencies (US$) in 2008?
Your response must be concise. 2.02e+08. 